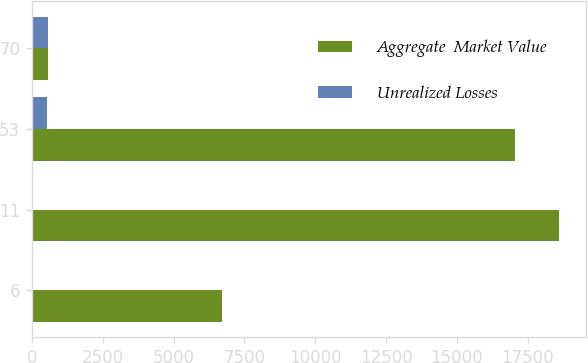Convert chart. <chart><loc_0><loc_0><loc_500><loc_500><stacked_bar_chart><ecel><fcel>6<fcel>11<fcel>53<fcel>70<nl><fcel>Aggregate  Market Value<fcel>6708<fcel>18612<fcel>17057<fcel>572<nl><fcel>Unrealized Losses<fcel>4<fcel>36<fcel>532<fcel>572<nl></chart> 